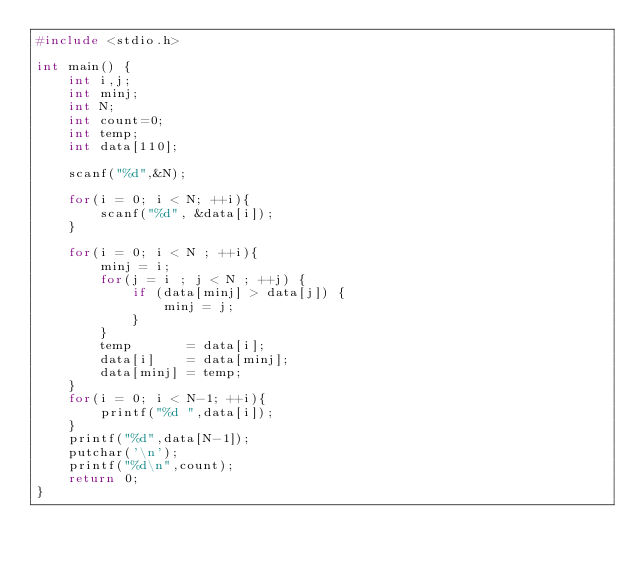<code> <loc_0><loc_0><loc_500><loc_500><_C_>#include <stdio.h>

int main() {
    int i,j;
    int minj;
    int N;
    int count=0;
    int temp;
    int data[110];

    scanf("%d",&N);

    for(i = 0; i < N; ++i){
        scanf("%d", &data[i]);
    }

    for(i = 0; i < N ; ++i){
        minj = i;
        for(j = i ; j < N ; ++j) {
            if (data[minj] > data[j]) {
                minj = j;
            }
        }
        temp       = data[i];
        data[i]    = data[minj];
        data[minj] = temp;
    }
    for(i = 0; i < N-1; ++i){
        printf("%d ",data[i]);
    }
    printf("%d",data[N-1]);
    putchar('\n');
    printf("%d\n",count);
    return 0;
}
</code> 